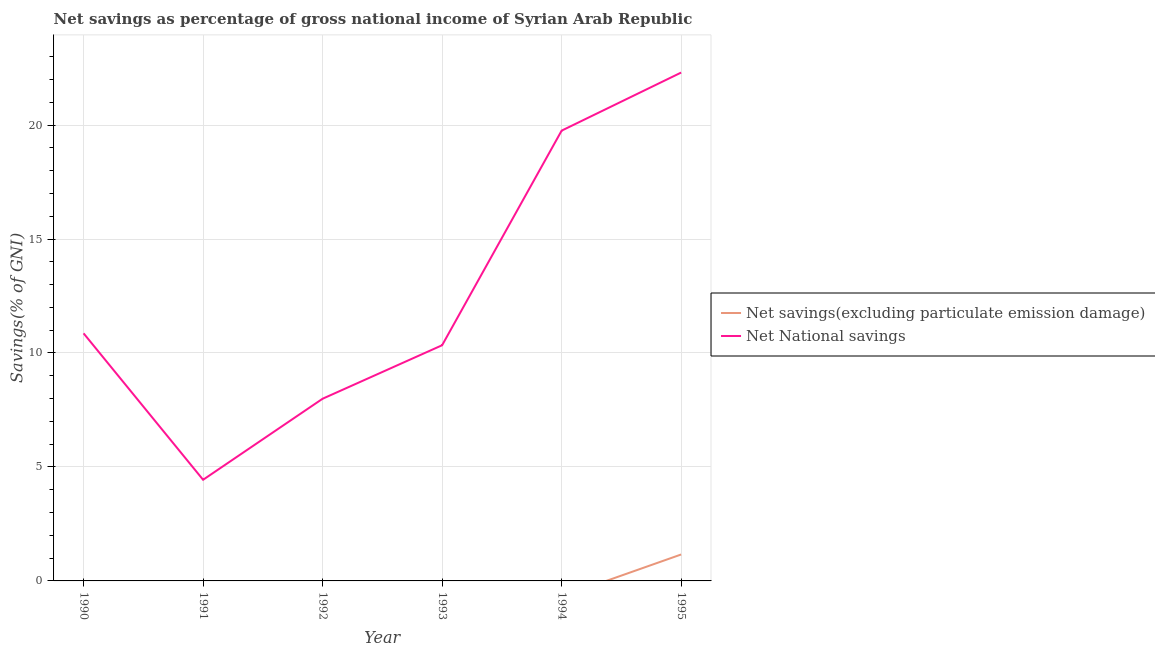How many different coloured lines are there?
Your response must be concise. 2. Does the line corresponding to net national savings intersect with the line corresponding to net savings(excluding particulate emission damage)?
Keep it short and to the point. No. What is the net national savings in 1995?
Keep it short and to the point. 22.3. Across all years, what is the maximum net national savings?
Offer a very short reply. 22.3. Across all years, what is the minimum net savings(excluding particulate emission damage)?
Make the answer very short. 0. In which year was the net savings(excluding particulate emission damage) maximum?
Your answer should be very brief. 1995. What is the total net national savings in the graph?
Your response must be concise. 75.69. What is the difference between the net national savings in 1990 and that in 1995?
Provide a short and direct response. -11.44. What is the difference between the net savings(excluding particulate emission damage) in 1994 and the net national savings in 1990?
Your answer should be compact. -10.86. What is the average net national savings per year?
Your answer should be compact. 12.61. In the year 1995, what is the difference between the net savings(excluding particulate emission damage) and net national savings?
Offer a very short reply. -21.14. What is the ratio of the net national savings in 1990 to that in 1993?
Your answer should be compact. 1.05. What is the difference between the highest and the second highest net national savings?
Keep it short and to the point. 2.55. What is the difference between the highest and the lowest net savings(excluding particulate emission damage)?
Ensure brevity in your answer.  1.16. In how many years, is the net savings(excluding particulate emission damage) greater than the average net savings(excluding particulate emission damage) taken over all years?
Your response must be concise. 1. Does the net national savings monotonically increase over the years?
Your response must be concise. No. How many lines are there?
Offer a terse response. 2. Where does the legend appear in the graph?
Your answer should be very brief. Center right. What is the title of the graph?
Provide a succinct answer. Net savings as percentage of gross national income of Syrian Arab Republic. Does "Rural" appear as one of the legend labels in the graph?
Keep it short and to the point. No. What is the label or title of the Y-axis?
Provide a succinct answer. Savings(% of GNI). What is the Savings(% of GNI) in Net National savings in 1990?
Offer a terse response. 10.86. What is the Savings(% of GNI) in Net National savings in 1991?
Provide a succinct answer. 4.44. What is the Savings(% of GNI) in Net National savings in 1992?
Keep it short and to the point. 7.99. What is the Savings(% of GNI) in Net savings(excluding particulate emission damage) in 1993?
Keep it short and to the point. 0. What is the Savings(% of GNI) of Net National savings in 1993?
Give a very brief answer. 10.34. What is the Savings(% of GNI) in Net National savings in 1994?
Provide a succinct answer. 19.75. What is the Savings(% of GNI) in Net savings(excluding particulate emission damage) in 1995?
Make the answer very short. 1.16. What is the Savings(% of GNI) in Net National savings in 1995?
Your response must be concise. 22.3. Across all years, what is the maximum Savings(% of GNI) in Net savings(excluding particulate emission damage)?
Offer a terse response. 1.16. Across all years, what is the maximum Savings(% of GNI) in Net National savings?
Your response must be concise. 22.3. Across all years, what is the minimum Savings(% of GNI) in Net National savings?
Provide a short and direct response. 4.44. What is the total Savings(% of GNI) in Net savings(excluding particulate emission damage) in the graph?
Ensure brevity in your answer.  1.16. What is the total Savings(% of GNI) in Net National savings in the graph?
Offer a terse response. 75.69. What is the difference between the Savings(% of GNI) of Net National savings in 1990 and that in 1991?
Offer a very short reply. 6.42. What is the difference between the Savings(% of GNI) of Net National savings in 1990 and that in 1992?
Offer a very short reply. 2.87. What is the difference between the Savings(% of GNI) of Net National savings in 1990 and that in 1993?
Your answer should be compact. 0.52. What is the difference between the Savings(% of GNI) of Net National savings in 1990 and that in 1994?
Your response must be concise. -8.89. What is the difference between the Savings(% of GNI) in Net National savings in 1990 and that in 1995?
Your response must be concise. -11.44. What is the difference between the Savings(% of GNI) of Net National savings in 1991 and that in 1992?
Offer a very short reply. -3.56. What is the difference between the Savings(% of GNI) of Net National savings in 1991 and that in 1993?
Provide a short and direct response. -5.9. What is the difference between the Savings(% of GNI) in Net National savings in 1991 and that in 1994?
Provide a short and direct response. -15.32. What is the difference between the Savings(% of GNI) in Net National savings in 1991 and that in 1995?
Provide a short and direct response. -17.86. What is the difference between the Savings(% of GNI) in Net National savings in 1992 and that in 1993?
Offer a very short reply. -2.35. What is the difference between the Savings(% of GNI) of Net National savings in 1992 and that in 1994?
Provide a short and direct response. -11.76. What is the difference between the Savings(% of GNI) of Net National savings in 1992 and that in 1995?
Ensure brevity in your answer.  -14.31. What is the difference between the Savings(% of GNI) in Net National savings in 1993 and that in 1994?
Offer a very short reply. -9.41. What is the difference between the Savings(% of GNI) of Net National savings in 1993 and that in 1995?
Your answer should be very brief. -11.96. What is the difference between the Savings(% of GNI) in Net National savings in 1994 and that in 1995?
Your answer should be compact. -2.55. What is the average Savings(% of GNI) of Net savings(excluding particulate emission damage) per year?
Ensure brevity in your answer.  0.19. What is the average Savings(% of GNI) of Net National savings per year?
Your answer should be very brief. 12.61. In the year 1995, what is the difference between the Savings(% of GNI) in Net savings(excluding particulate emission damage) and Savings(% of GNI) in Net National savings?
Keep it short and to the point. -21.14. What is the ratio of the Savings(% of GNI) in Net National savings in 1990 to that in 1991?
Offer a terse response. 2.45. What is the ratio of the Savings(% of GNI) in Net National savings in 1990 to that in 1992?
Ensure brevity in your answer.  1.36. What is the ratio of the Savings(% of GNI) of Net National savings in 1990 to that in 1993?
Offer a very short reply. 1.05. What is the ratio of the Savings(% of GNI) of Net National savings in 1990 to that in 1994?
Keep it short and to the point. 0.55. What is the ratio of the Savings(% of GNI) of Net National savings in 1990 to that in 1995?
Make the answer very short. 0.49. What is the ratio of the Savings(% of GNI) of Net National savings in 1991 to that in 1992?
Your answer should be very brief. 0.56. What is the ratio of the Savings(% of GNI) of Net National savings in 1991 to that in 1993?
Make the answer very short. 0.43. What is the ratio of the Savings(% of GNI) in Net National savings in 1991 to that in 1994?
Offer a terse response. 0.22. What is the ratio of the Savings(% of GNI) of Net National savings in 1991 to that in 1995?
Your response must be concise. 0.2. What is the ratio of the Savings(% of GNI) in Net National savings in 1992 to that in 1993?
Provide a succinct answer. 0.77. What is the ratio of the Savings(% of GNI) in Net National savings in 1992 to that in 1994?
Give a very brief answer. 0.4. What is the ratio of the Savings(% of GNI) of Net National savings in 1992 to that in 1995?
Offer a very short reply. 0.36. What is the ratio of the Savings(% of GNI) of Net National savings in 1993 to that in 1994?
Keep it short and to the point. 0.52. What is the ratio of the Savings(% of GNI) in Net National savings in 1993 to that in 1995?
Offer a terse response. 0.46. What is the ratio of the Savings(% of GNI) of Net National savings in 1994 to that in 1995?
Make the answer very short. 0.89. What is the difference between the highest and the second highest Savings(% of GNI) in Net National savings?
Make the answer very short. 2.55. What is the difference between the highest and the lowest Savings(% of GNI) in Net savings(excluding particulate emission damage)?
Ensure brevity in your answer.  1.16. What is the difference between the highest and the lowest Savings(% of GNI) in Net National savings?
Your answer should be very brief. 17.86. 